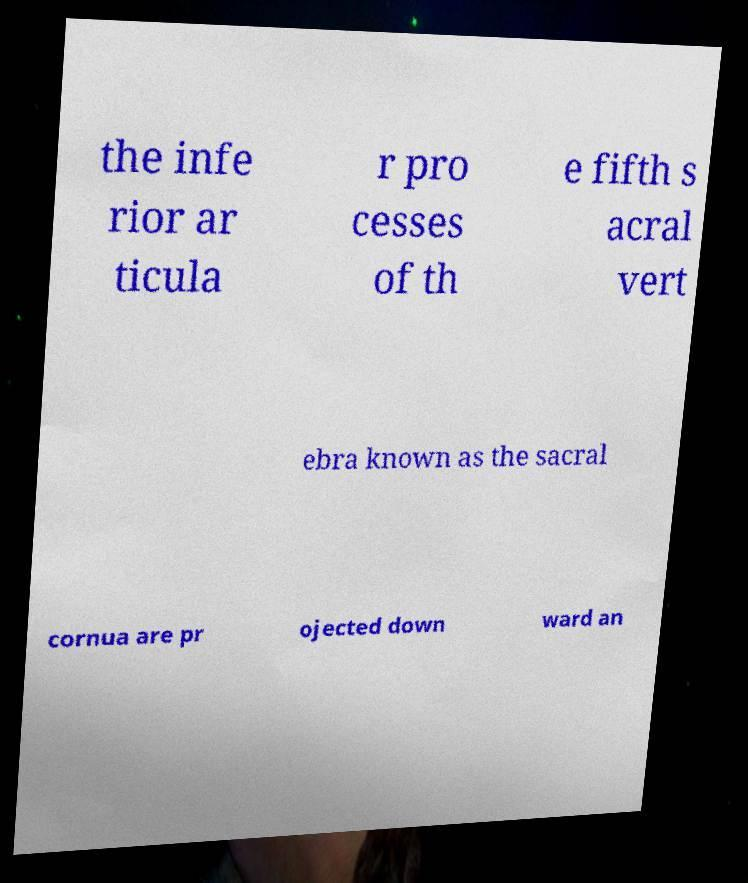There's text embedded in this image that I need extracted. Can you transcribe it verbatim? the infe rior ar ticula r pro cesses of th e fifth s acral vert ebra known as the sacral cornua are pr ojected down ward an 